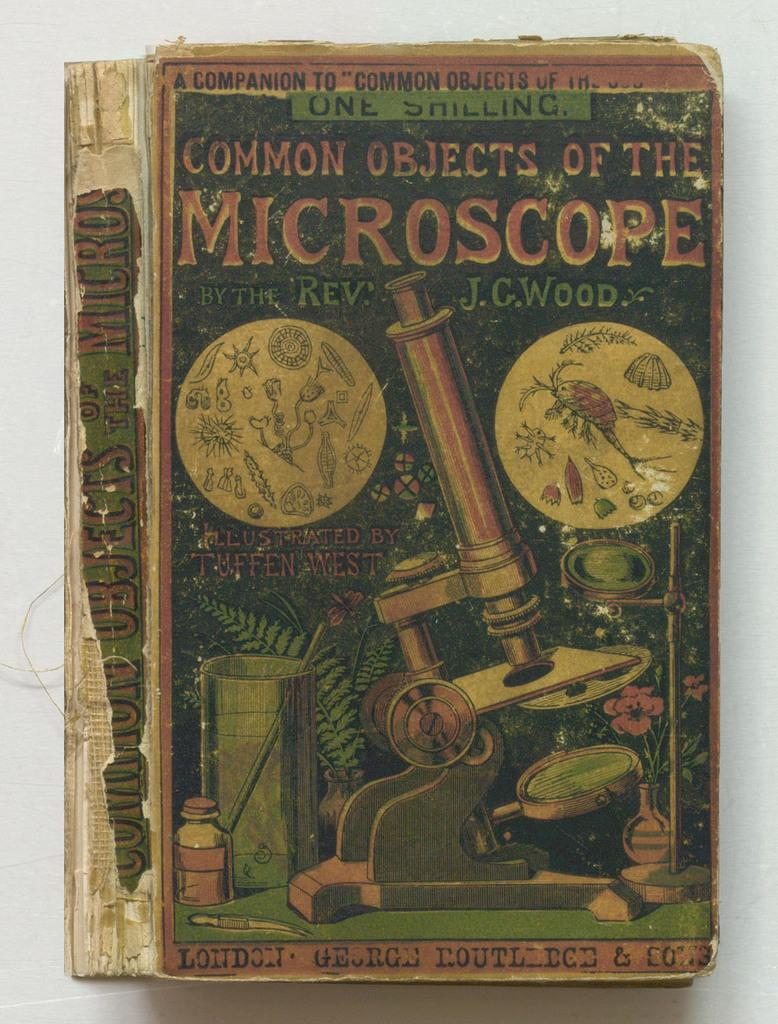<image>
Share a concise interpretation of the image provided. Chapter book about common objects of the microscope 